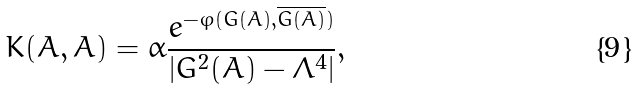Convert formula to latex. <formula><loc_0><loc_0><loc_500><loc_500>K ( A , \bar { A } ) = \alpha \frac { e ^ { - \varphi ( G ( A ) , \overline { G ( A ) } ) } } { | G ^ { 2 } ( A ) - \Lambda ^ { 4 } | } ,</formula> 